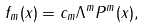Convert formula to latex. <formula><loc_0><loc_0><loc_500><loc_500>f _ { m } ( x ) = c _ { m } \Lambda ^ { m } P ^ { m } ( x ) ,</formula> 